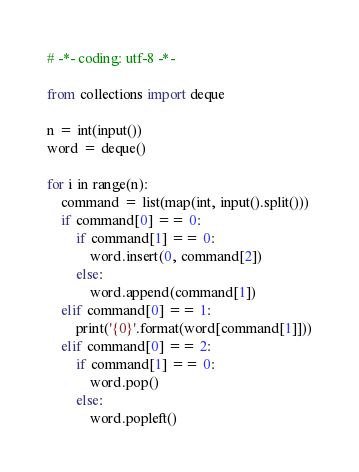Convert code to text. <code><loc_0><loc_0><loc_500><loc_500><_Python_># -*- coding: utf-8 -*-

from collections import deque

n = int(input())
word = deque()

for i in range(n):
    command = list(map(int, input().split()))
    if command[0] == 0:
        if command[1] == 0:
            word.insert(0, command[2])
        else:
            word.append(command[1])
    elif command[0] == 1:
        print('{0}'.format(word[command[1]]))
    elif command[0] == 2:
        if command[1] == 0:
            word.pop()
        else:
            word.popleft()

</code> 